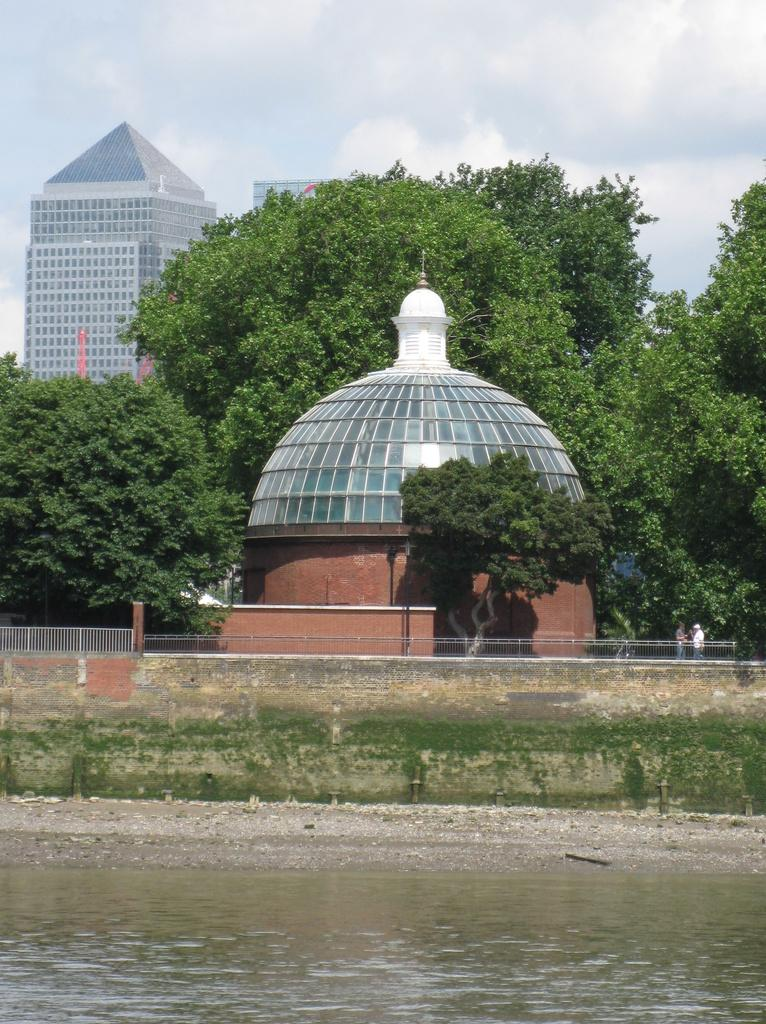What is present at the bottom of the picture? There is water at the bottom of the picture. What type of structure can be seen in the image? There is a compound wall in the image. What feature is present to provide safety or support? There are railings in the image. What type of vegetation is visible in the image? There are trees in the image. What type of man-made structures are present in the image? There are buildings in the image. How would you describe the weather condition in the image? The sky is cloudy in the image. How does the heat affect the pump in the image? There is no pump present in the image, so it is not possible to determine how heat might affect it. 